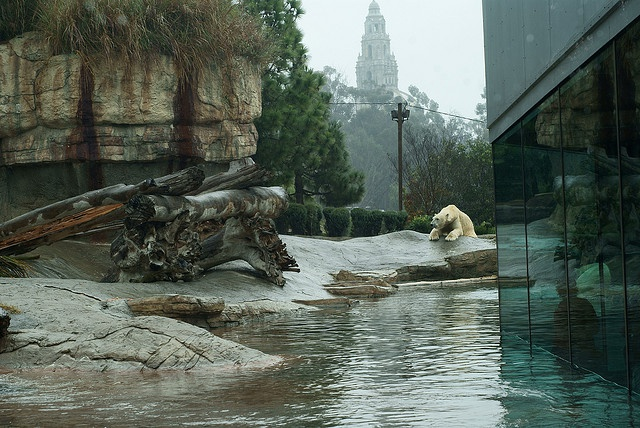Describe the objects in this image and their specific colors. I can see people in black, teal, and darkgreen tones and bear in black, beige, tan, and gray tones in this image. 